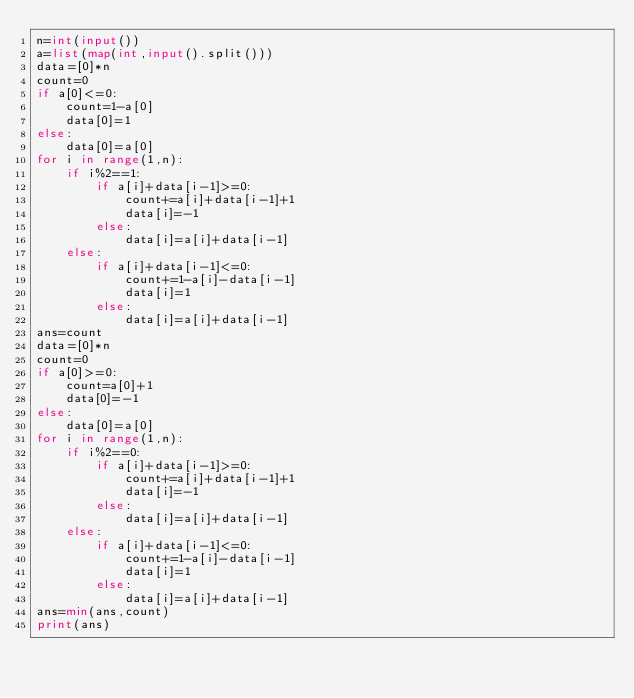<code> <loc_0><loc_0><loc_500><loc_500><_Python_>n=int(input())
a=list(map(int,input().split()))
data=[0]*n
count=0
if a[0]<=0:
    count=1-a[0]
    data[0]=1
else:
    data[0]=a[0]
for i in range(1,n):
    if i%2==1:
        if a[i]+data[i-1]>=0:
            count+=a[i]+data[i-1]+1
            data[i]=-1
        else:
            data[i]=a[i]+data[i-1]
    else:
        if a[i]+data[i-1]<=0:
            count+=1-a[i]-data[i-1]
            data[i]=1
        else:
            data[i]=a[i]+data[i-1]
ans=count
data=[0]*n
count=0
if a[0]>=0:
    count=a[0]+1
    data[0]=-1
else:
    data[0]=a[0]
for i in range(1,n):
    if i%2==0:
        if a[i]+data[i-1]>=0:
            count+=a[i]+data[i-1]+1
            data[i]=-1
        else:
            data[i]=a[i]+data[i-1]
    else:
        if a[i]+data[i-1]<=0:
            count+=1-a[i]-data[i-1]
            data[i]=1
        else:
            data[i]=a[i]+data[i-1]
ans=min(ans,count)
print(ans)</code> 